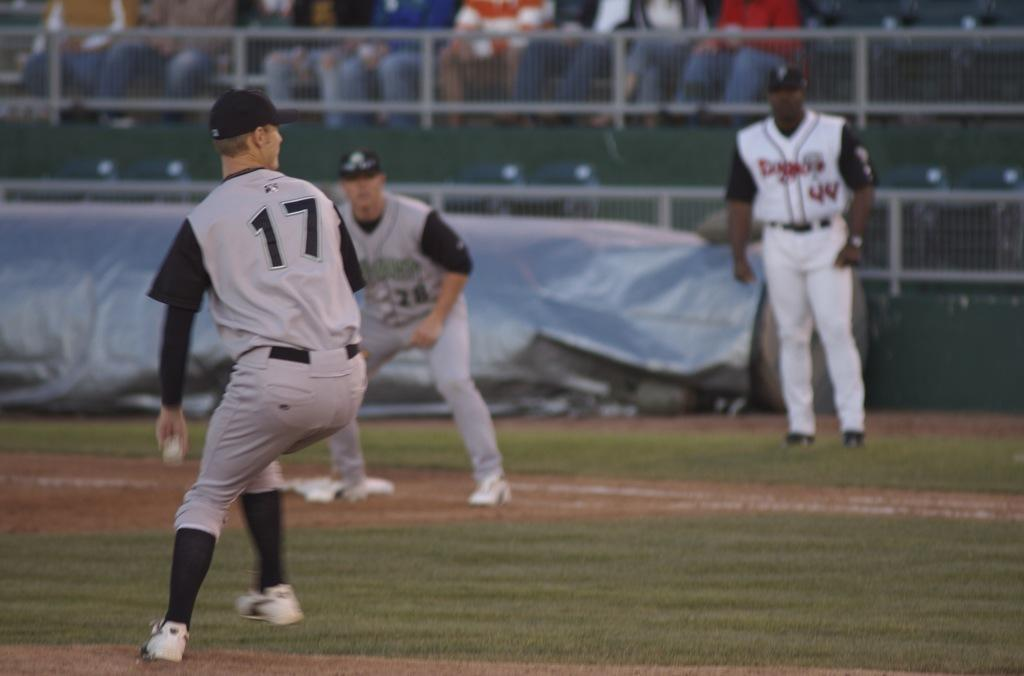<image>
Summarize the visual content of the image. A ball player with number 17 on his uniform winds up for a pitch. 